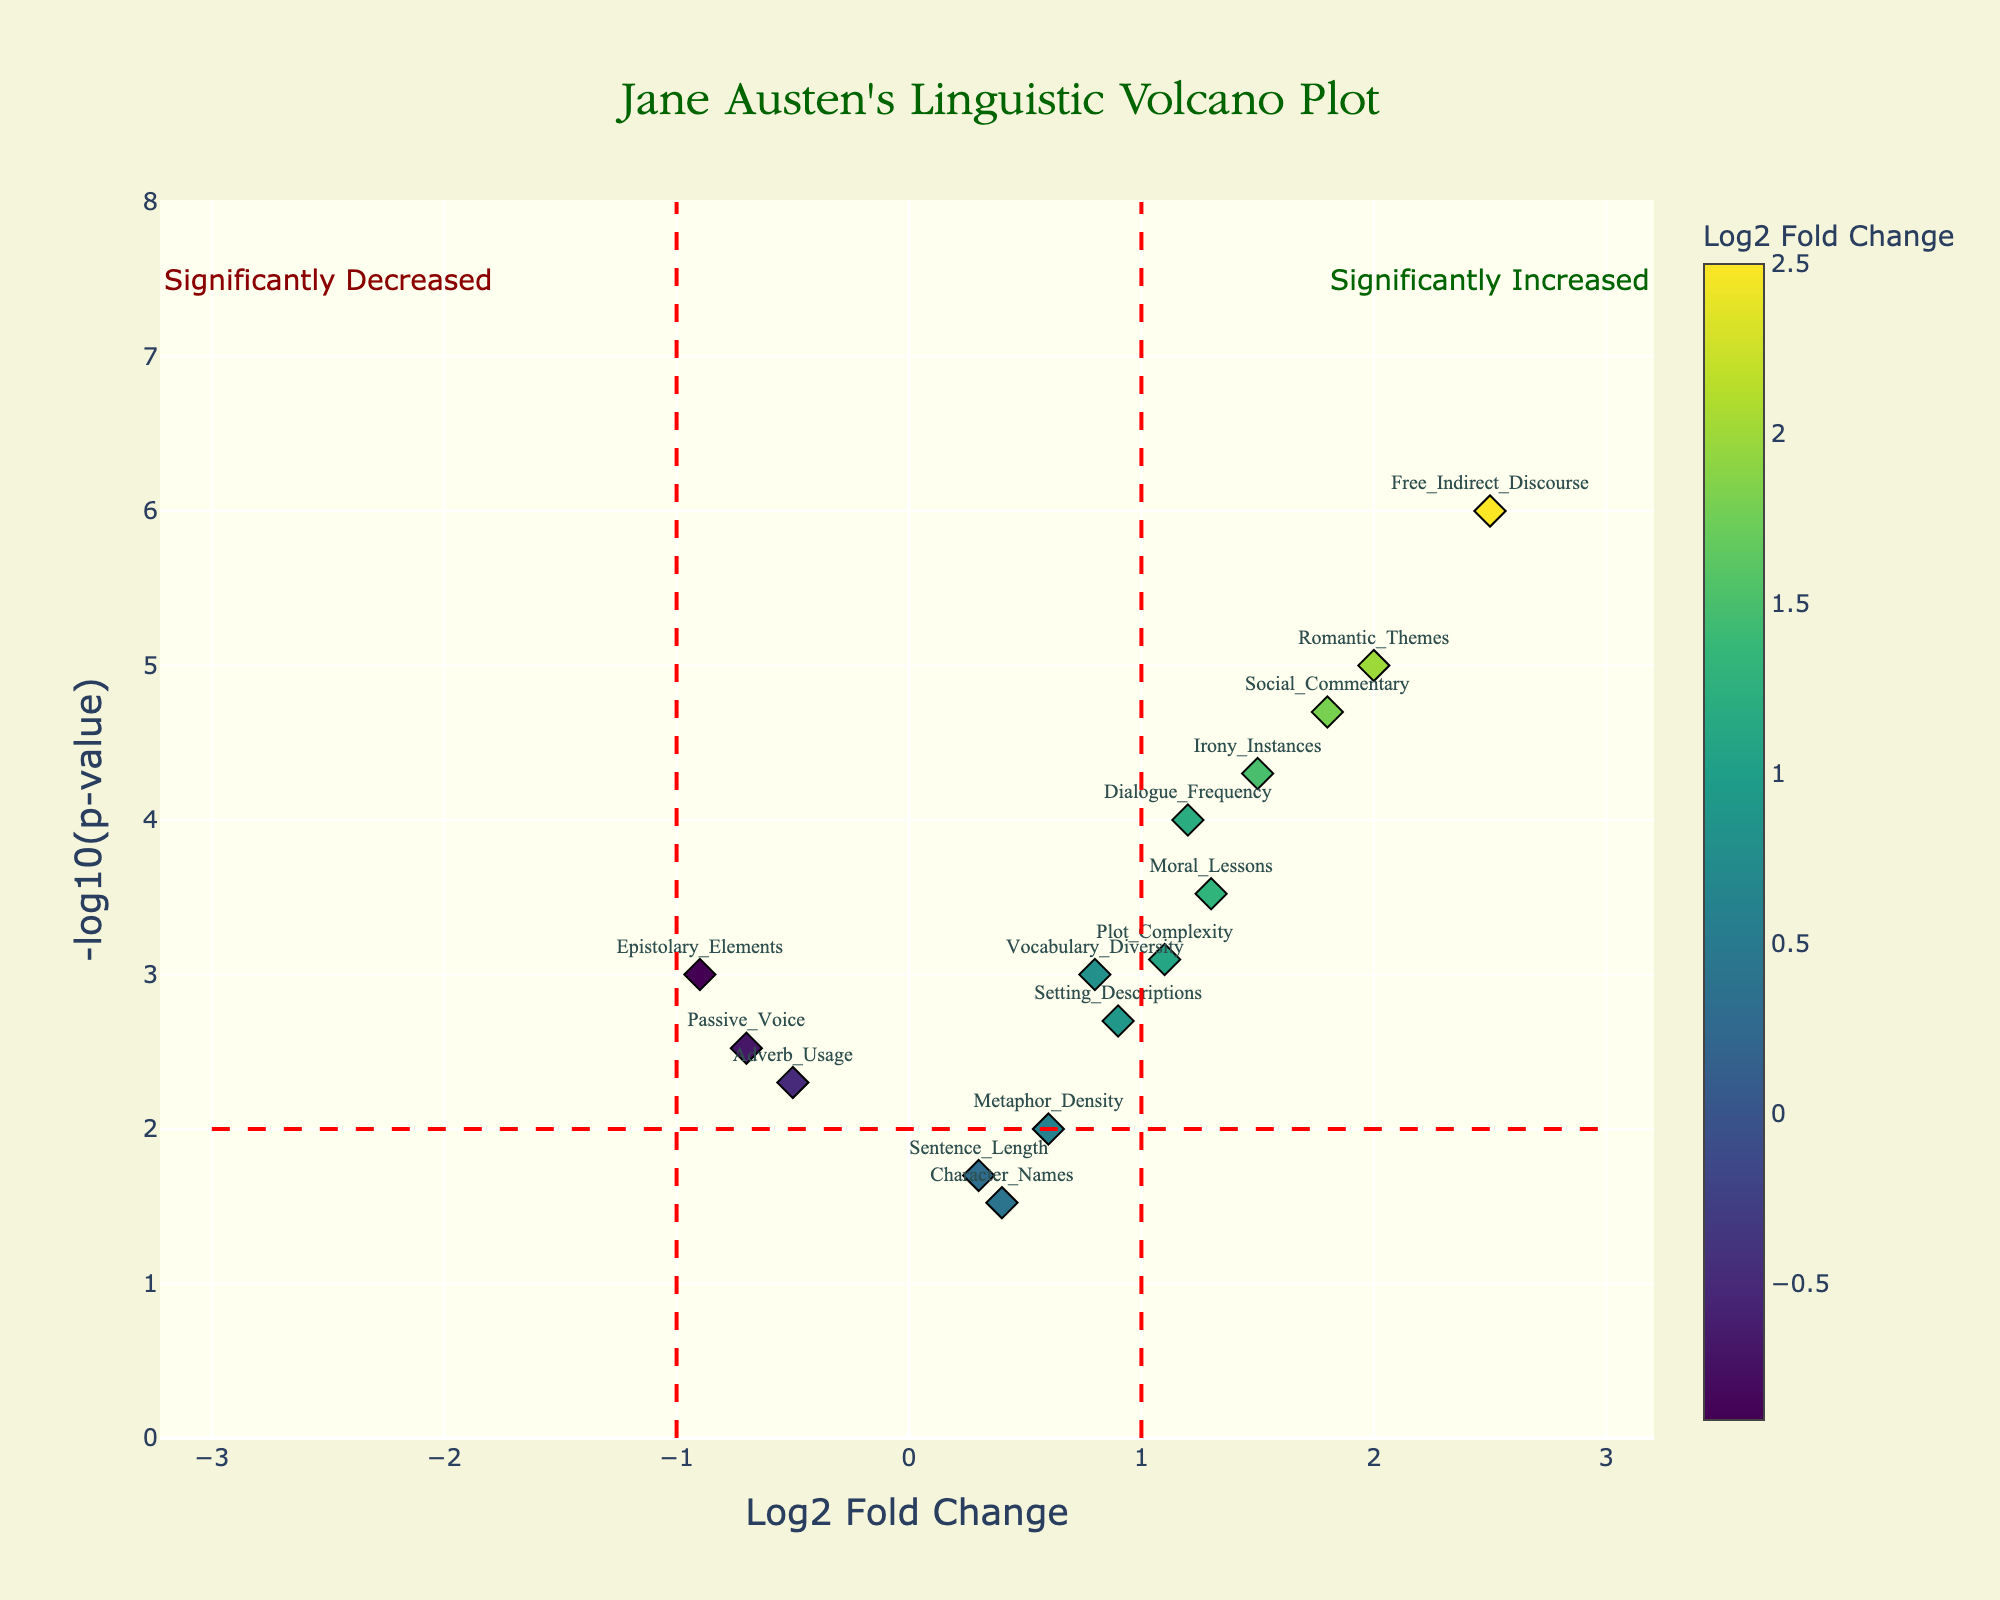What is the title of the figure? The title is usually displayed prominently at the top of the plot. In this case, the title is given in the `update_layout` function in the code, so by identifying the title, we understand the main subject of the plot.
Answer: Jane Austen's Linguistic Volcano Plot Which gene has the highest -log10(p-value) in the plot? By examining the y-axis (representing -log10(p-value)) and identifying which point is positioned at the highest point on the vertical axis, we can find the gene with the highest -log10(p-value). From the hover information, it's easy to deduce.
Answer: Free_Indirect_Discourse What is the Log2 Fold Change for "Romantic_Themes"? By locating the point labeled "Romantic_Themes" on the plot and noting its position on the x-axis, we can determine the Log2 Fold Change value. According to the provided data, this value is easy to find.
Answer: 2.0 How many data points have a negative Log2 Fold Change? Points with negative Log2 Fold Change are those located to the left of the y-axis (Log2 Fold Change < 0). Counting these points on the plot gives us the answer. There are three such data points.
Answer: 3 Which two genes have the closest Log2 Fold Change values, and what are those values? By comparing the x-axis positions of all points in the plot, we can identify which two points are closest to each other. In the data provided, "Character_Names" and "Sentence_Length" are close. Their values are used for the answer.
Answer: Character_Names (0.4), Sentence_Length (0.3) Which gene shows the most significant increase in Log2 Fold Change, and what is its significance line? The most significant increase would be the data point farthest to the right with the highest -log10(p-value). It's "Free_Indirect_Discourse". The significance line would be the red one marking 1 on the y-axis.
Answer: Free_Indirect_Discourse, 1 How is "Dialogue_Frequency" represented in terms of Log2 Fold Change and -log10(p-value)? By observing the coordinates of the point labeled "Dialogue_Frequency" on the plot, we can note its Log2 Fold Change and -log10(p-value) values. These values are useful for understanding its significance in the plot.
Answer: Log2FC: 1.2, -log10(p-value): 4.0 Which elements are identified as significantly decreased? Points labeled "Adverb_Usage," "Passive_Voice," and "Epistolary_Elements" are all located to the left of the y-axis and above the significance line, showing a significant decrease in Log2 Fold Change.
Answer: Adverb_Usage, Passive_Voice, Epistolary_Elements Comparing "Irony_Instances" and "Social_Commentary," which one has a lower p-value? By comparing their -log10(p-values), the higher the value, the lower the p-value. So, looking at their y-axis positions, "Irony_Instances" has a higher -log10(p-value) than "Social_Commentary".
Answer: Irony_Instances 